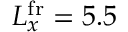<formula> <loc_0><loc_0><loc_500><loc_500>L _ { x } ^ { f r } = 5 . 5</formula> 